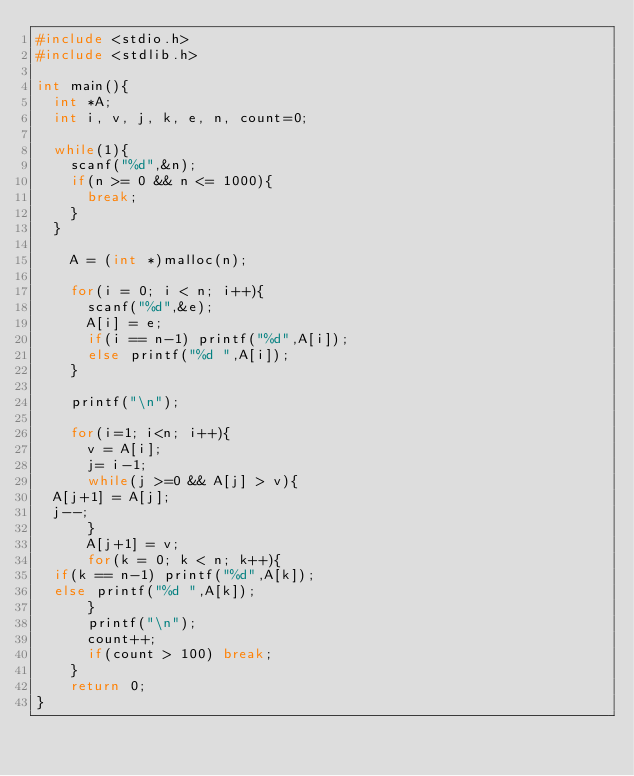Convert code to text. <code><loc_0><loc_0><loc_500><loc_500><_C_>#include <stdio.h>
#include <stdlib.h>

int main(){
  int *A;
  int i, v, j, k, e, n, count=0;

  while(1){
    scanf("%d",&n);
    if(n >= 0 && n <= 1000){
      break;
    }
  }

    A = (int *)malloc(n);
  
    for(i = 0; i < n; i++){
      scanf("%d",&e);
      A[i] = e;
      if(i == n-1) printf("%d",A[i]);
      else printf("%d ",A[i]);
    }

    printf("\n");

    for(i=1; i<n; i++){
      v = A[i];
      j= i-1;
      while(j >=0 && A[j] > v){
	A[j+1] = A[j];
	j--;
      }
      A[j+1] = v;
      for(k = 0; k < n; k++){
	if(k == n-1) printf("%d",A[k]);
	else printf("%d ",A[k]);
      }
      printf("\n");
      count++;
      if(count > 100) break;
    }
    return 0;
}</code> 